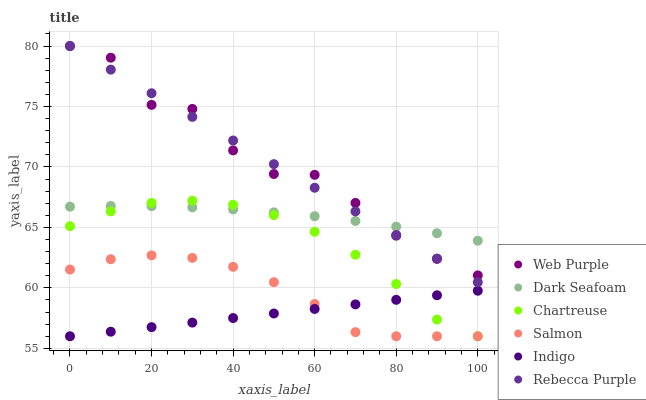Does Indigo have the minimum area under the curve?
Answer yes or no. Yes. Does Web Purple have the maximum area under the curve?
Answer yes or no. Yes. Does Salmon have the minimum area under the curve?
Answer yes or no. No. Does Salmon have the maximum area under the curve?
Answer yes or no. No. Is Indigo the smoothest?
Answer yes or no. Yes. Is Web Purple the roughest?
Answer yes or no. Yes. Is Salmon the smoothest?
Answer yes or no. No. Is Salmon the roughest?
Answer yes or no. No. Does Indigo have the lowest value?
Answer yes or no. Yes. Does Dark Seafoam have the lowest value?
Answer yes or no. No. Does Rebecca Purple have the highest value?
Answer yes or no. Yes. Does Salmon have the highest value?
Answer yes or no. No. Is Indigo less than Dark Seafoam?
Answer yes or no. Yes. Is Web Purple greater than Indigo?
Answer yes or no. Yes. Does Dark Seafoam intersect Rebecca Purple?
Answer yes or no. Yes. Is Dark Seafoam less than Rebecca Purple?
Answer yes or no. No. Is Dark Seafoam greater than Rebecca Purple?
Answer yes or no. No. Does Indigo intersect Dark Seafoam?
Answer yes or no. No. 